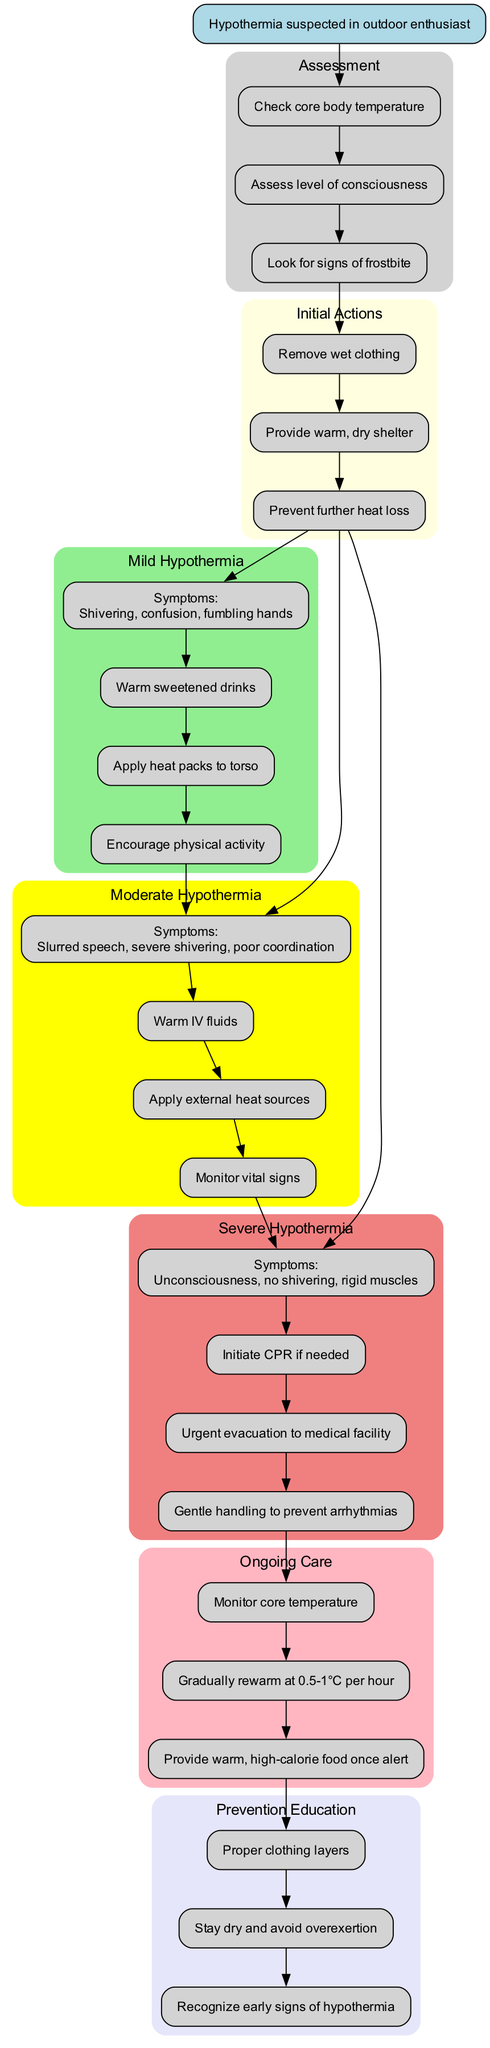What is the first step in the pathway? The first step indicated in the diagram is to suspect hypothermia in the outdoor enthusiast, which serves as the starting point for the clinical pathway.
Answer: Hypothermia suspected in outdoor enthusiast How many symptoms are listed for moderate hypothermia? The moderate hypothermia section has three symptoms listed (slurred speech, severe shivering, poor coordination), thus leading to the conclusion based on counting the items within that section.
Answer: 3 What action should be taken after checking core body temperature? After checking the core body temperature, the next action is to assess the level of consciousness, which follows directly in the pathway.
Answer: Assess level of consciousness What are the treatments for severe hypothermia? The treatments listed under severe hypothermia include initiating CPR if needed, urgent evacuation to a medical facility, and gentle handling to prevent arrhythmias. Therefore, these are the steps indicated in the diagram for handling severe hypothermia.
Answer: Initiate CPR if needed, urgent evacuation to medical facility, gentle handling to prevent arrhythmias Which section follows the symptoms of mild hypothermia? The treatment for mild hypothermia follows the symptoms. Thus, after identifying symptoms such as shivering and confusion, the next action is to provide the corresponding treatment listed under that category.
Answer: Treatment for mild hypothermia How many actions are specified in the initial actions cluster? The initial actions cluster includes three actions (remove wet clothing, provide warm and dry shelter, prevent further heat loss), which can be counted directly by reviewing the items in that section of the diagram.
Answer: 3 What should be monitored during ongoing care? The ongoing care section specifies that core temperature should be monitored, which is a critical aspect of patient management after treatment for hypothermia.
Answer: Monitor core temperature What education should be provided to prevent hypothermia? The prevention education cluster indicates proper clothing layers, staying dry and avoiding overexertion, and recognizing early signs of hypothermia, hence summarizing the crucial educational points needed.
Answer: Proper clothing layers, stay dry and avoid overexertion, recognize early signs of hypothermia 